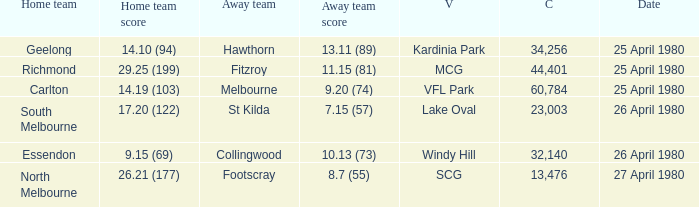On what date did the match at Lake Oval take place? 26 April 1980. 